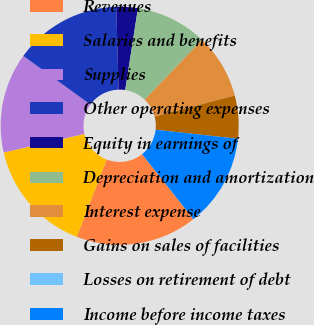Convert chart. <chart><loc_0><loc_0><loc_500><loc_500><pie_chart><fcel>Revenues<fcel>Salaries and benefits<fcel>Supplies<fcel>Other operating expenses<fcel>Equity in earnings of<fcel>Depreciation and amortization<fcel>Interest expense<fcel>Gains on sales of facilities<fcel>Losses on retirement of debt<fcel>Income before income taxes<nl><fcel>16.5%<fcel>15.53%<fcel>13.59%<fcel>14.56%<fcel>2.91%<fcel>9.71%<fcel>8.74%<fcel>5.83%<fcel>0.0%<fcel>12.62%<nl></chart> 